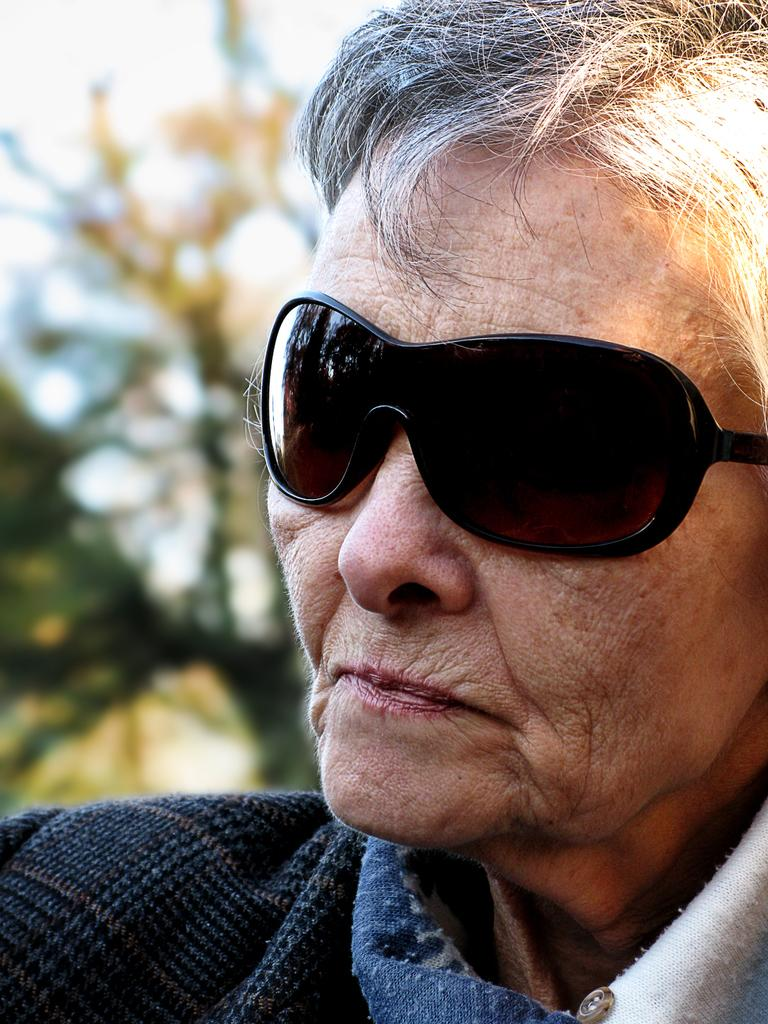Who or what is on the right side of the image? There is a person on the right side of the image. What is the person wearing in the image? The person is wearing goggles in the image. What can be seen in the background of the image? There is a tree in the background of the image. What is visible at the top of the image? The sky is visible at the top of the image. What type of crayon is the person using to draw in the image? There is no crayon present in the image, and the person is not drawing. 